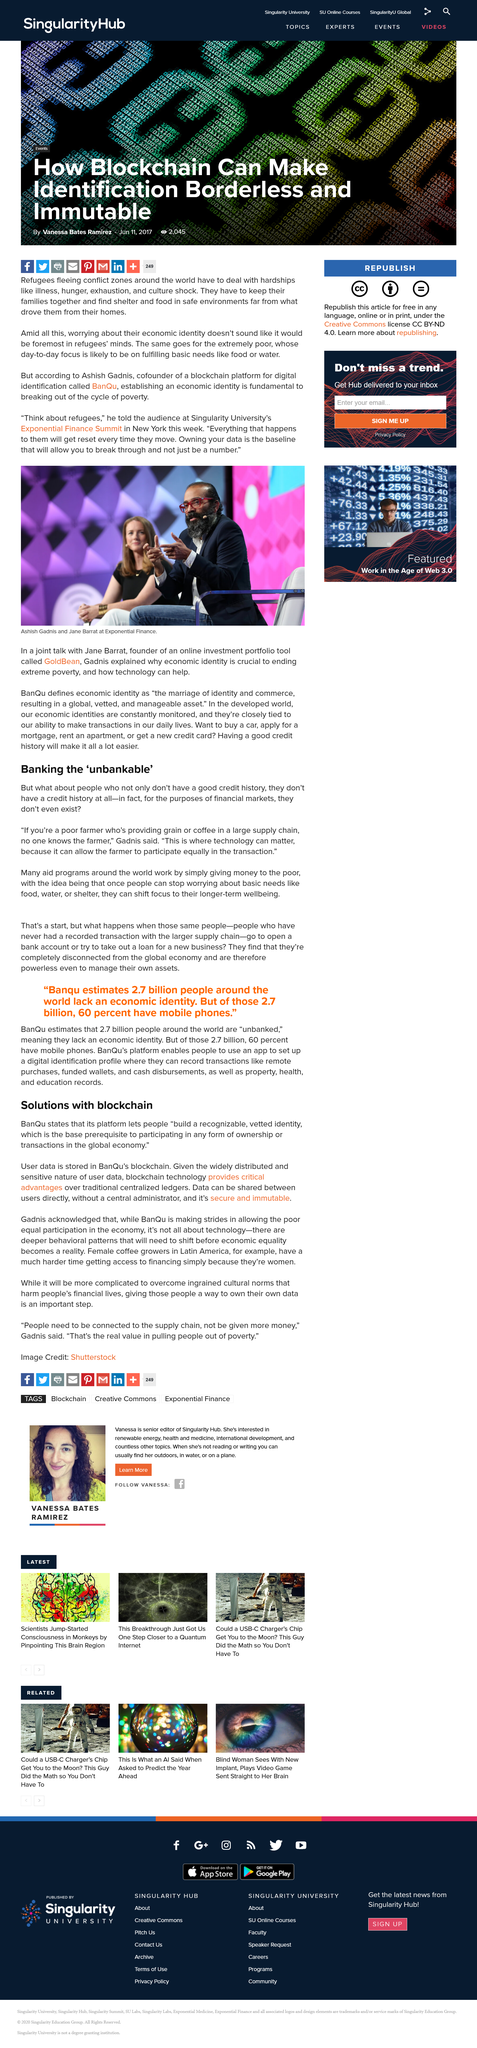List a handful of essential elements in this visual. Individuals with poor credit or no credit history at all may be deemed unbankable, as they may not have the financial history or creditworthiness required for traditional banking services. The piece is quoted in by Gadnis. Our platform empowers individuals to establish a trustworthy and verified identity, which is essential for participating in economic transactions and exercising ownership on a global scale. Data can be shared securely and immutably between users without a central administrator. BanQu stores user data on a blockchain. 